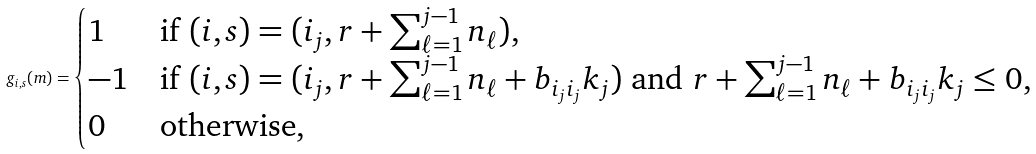<formula> <loc_0><loc_0><loc_500><loc_500>g _ { i , s } ( m ) = \begin{cases} 1 & \text {if } ( i , s ) = ( i _ { j } , r + \sum _ { \ell = 1 } ^ { j - 1 } n _ { \ell } ) , \\ - 1 & \text {if } ( i , s ) = ( i _ { j } , r + \sum _ { \ell = 1 } ^ { j - 1 } n _ { \ell } + b _ { i _ { j } i _ { j } } k _ { j } ) \text { and } r + \sum _ { \ell = 1 } ^ { j - 1 } n _ { \ell } + b _ { i _ { j } i _ { j } } k _ { j } \leq 0 , \\ 0 & \text {otherwise} , \end{cases}</formula> 